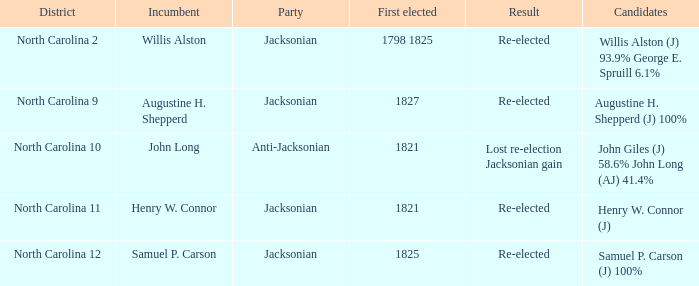Name the total number of party for willis alston 1.0. 